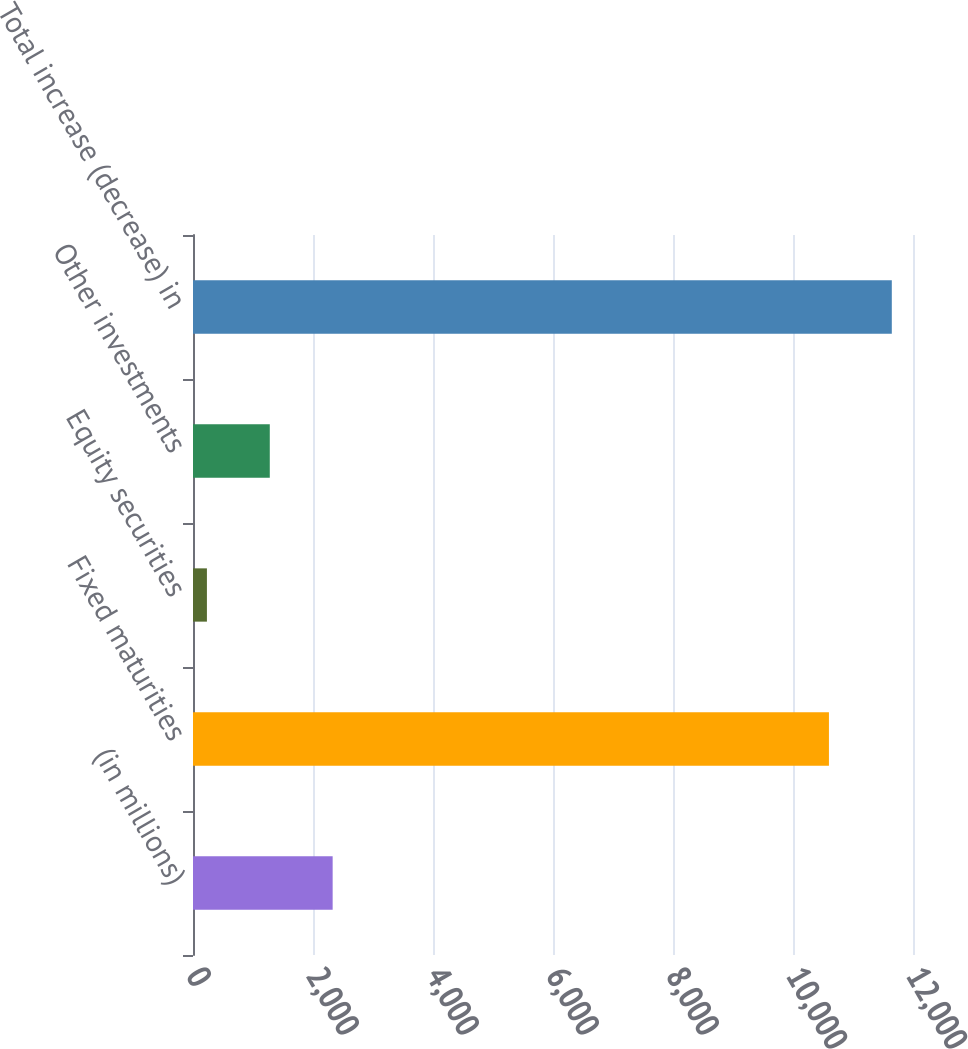Convert chart. <chart><loc_0><loc_0><loc_500><loc_500><bar_chart><fcel>(in millions)<fcel>Fixed maturities<fcel>Equity securities<fcel>Other investments<fcel>Total increase (decrease) in<nl><fcel>2327.6<fcel>10599<fcel>232<fcel>1279.8<fcel>11646.8<nl></chart> 